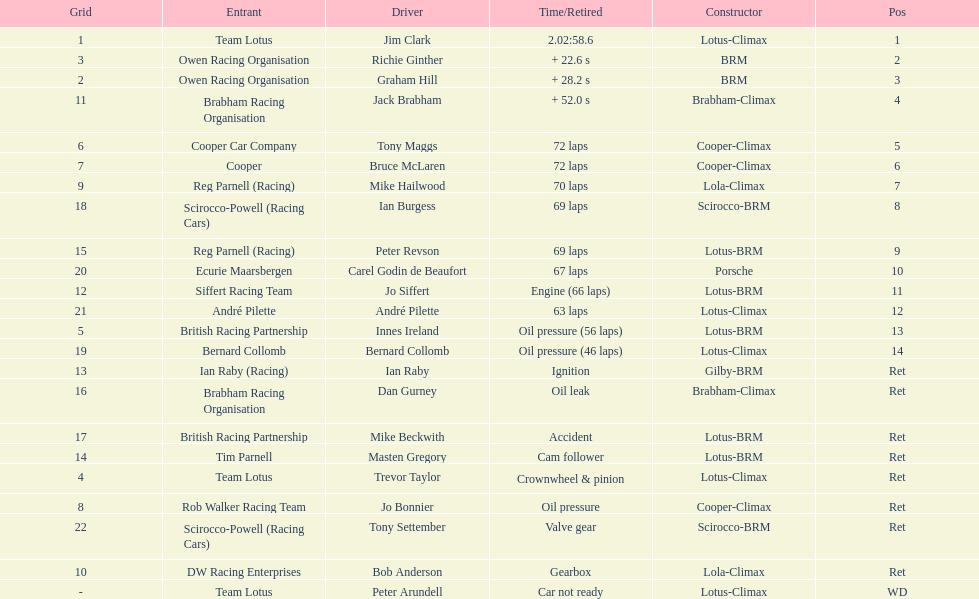Who drove in the 1963 international gold cup? Jim Clark, Richie Ginther, Graham Hill, Jack Brabham, Tony Maggs, Bruce McLaren, Mike Hailwood, Ian Burgess, Peter Revson, Carel Godin de Beaufort, Jo Siffert, André Pilette, Innes Ireland, Bernard Collomb, Ian Raby, Dan Gurney, Mike Beckwith, Masten Gregory, Trevor Taylor, Jo Bonnier, Tony Settember, Bob Anderson, Peter Arundell. Who had problems during the race? Jo Siffert, Innes Ireland, Bernard Collomb, Ian Raby, Dan Gurney, Mike Beckwith, Masten Gregory, Trevor Taylor, Jo Bonnier, Tony Settember, Bob Anderson, Peter Arundell. Of those who was still able to finish the race? Jo Siffert, Innes Ireland, Bernard Collomb. Of those who faced the same issue? Innes Ireland, Bernard Collomb. What issue did they have? Oil pressure. 